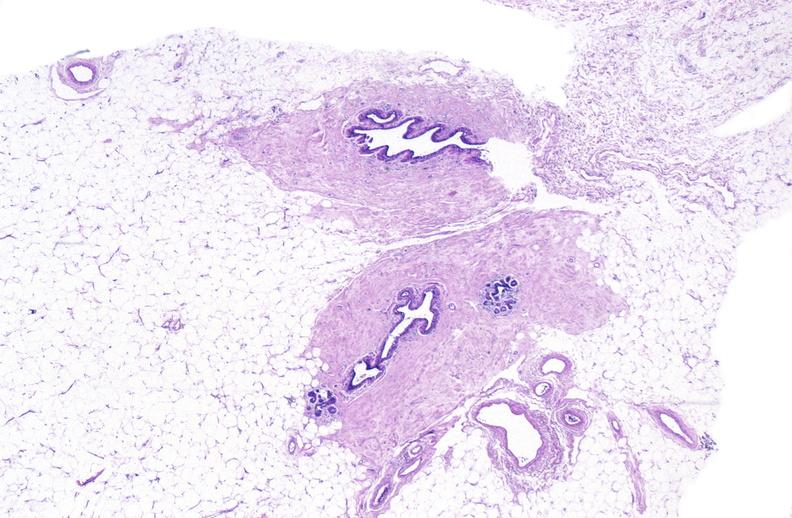where is this area in the body?
Answer the question using a single word or phrase. Breast 